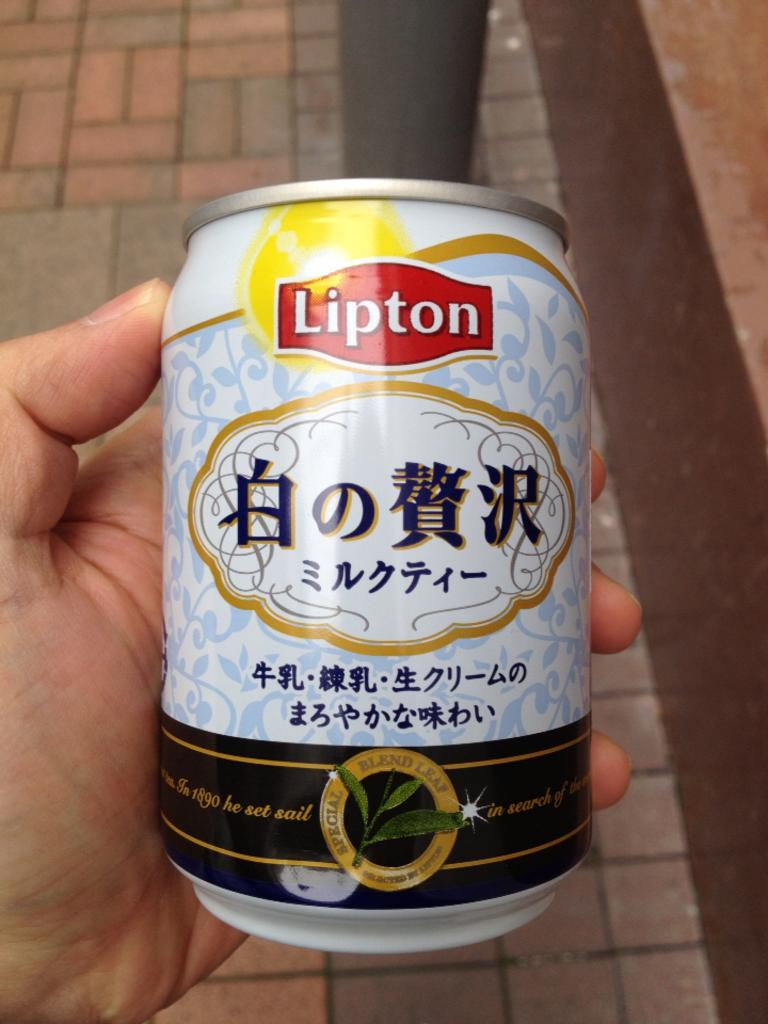<image>
Write a terse but informative summary of the picture. Person holding a small can that says Lipton on top. 